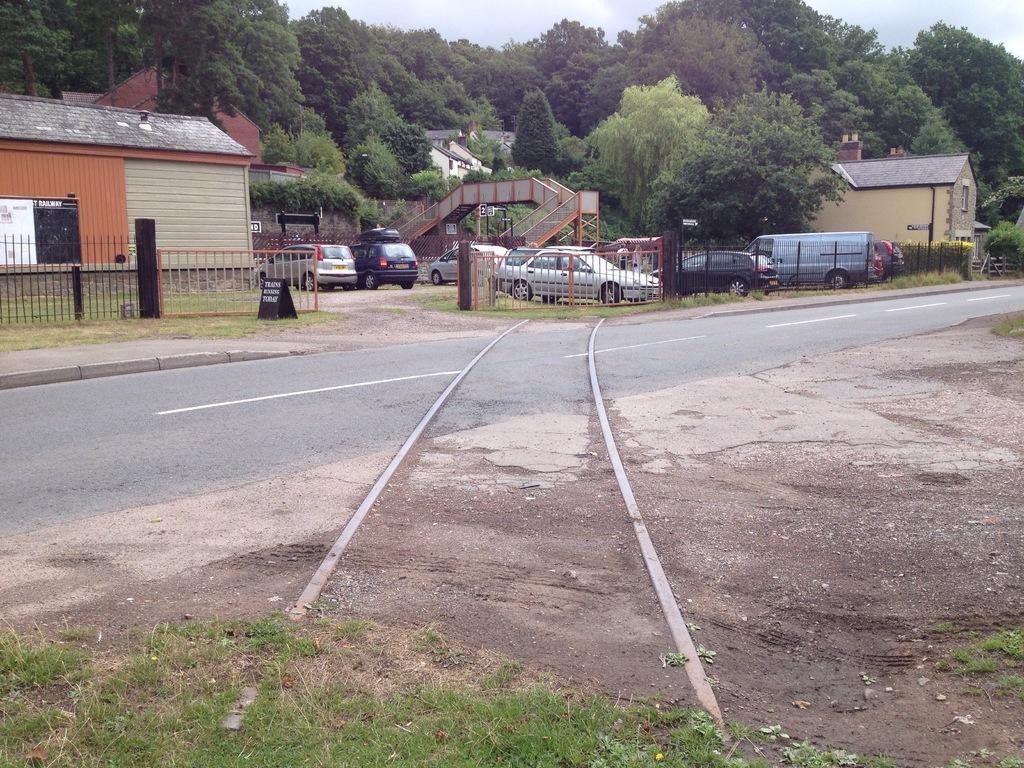Can you describe this image briefly? This image is clicked outside. There are trees at the top. There are stores in the middle. There are cars in the middle. There is sky at the top. 